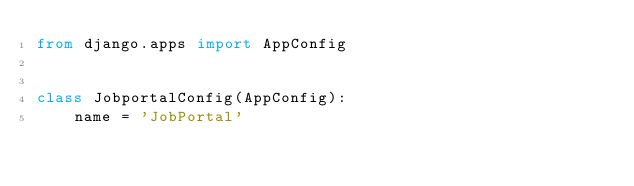Convert code to text. <code><loc_0><loc_0><loc_500><loc_500><_Python_>from django.apps import AppConfig


class JobportalConfig(AppConfig):
    name = 'JobPortal'
</code> 